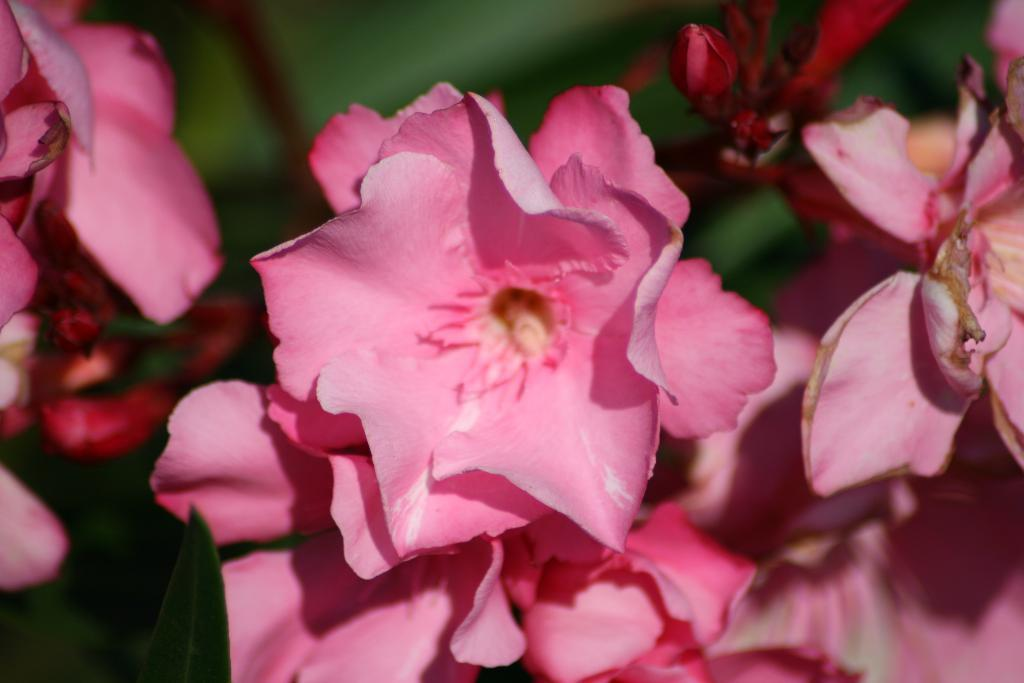What type of flora is present in the image? There are flowers in the image. What color are the flowers? The flowers are pink in color. What can be seen in the background of the image? The background of the image is green. How is the background of the image depicted? The background of the image is blurred. What sense of humor does the flower have in the image? The image does not depict a sense of humor for the flower, as it is a still image of flowers and not a living, sentient being. 